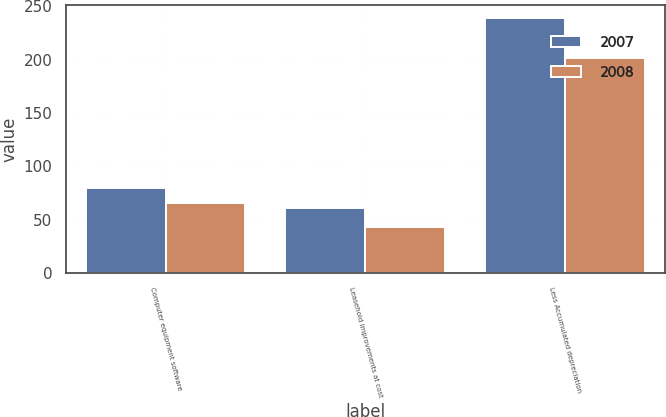Convert chart. <chart><loc_0><loc_0><loc_500><loc_500><stacked_bar_chart><ecel><fcel>Computer equipment software<fcel>Leasehold improvements at cost<fcel>Less Accumulated depreciation<nl><fcel>2007<fcel>80.2<fcel>61.2<fcel>238.9<nl><fcel>2008<fcel>65.6<fcel>43<fcel>201.8<nl></chart> 